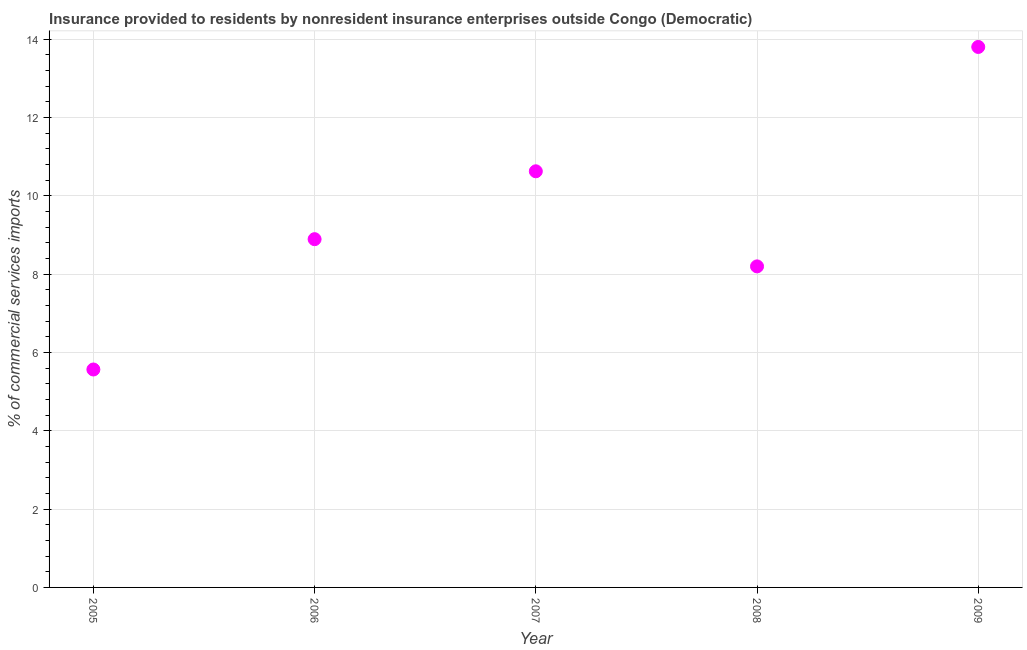What is the insurance provided by non-residents in 2009?
Your response must be concise. 13.8. Across all years, what is the maximum insurance provided by non-residents?
Give a very brief answer. 13.8. Across all years, what is the minimum insurance provided by non-residents?
Give a very brief answer. 5.57. In which year was the insurance provided by non-residents maximum?
Give a very brief answer. 2009. In which year was the insurance provided by non-residents minimum?
Offer a terse response. 2005. What is the sum of the insurance provided by non-residents?
Your answer should be very brief. 47.09. What is the difference between the insurance provided by non-residents in 2005 and 2008?
Your answer should be compact. -2.63. What is the average insurance provided by non-residents per year?
Your response must be concise. 9.42. What is the median insurance provided by non-residents?
Your response must be concise. 8.89. In how many years, is the insurance provided by non-residents greater than 9.2 %?
Your response must be concise. 2. Do a majority of the years between 2009 and 2007 (inclusive) have insurance provided by non-residents greater than 11.6 %?
Offer a very short reply. No. What is the ratio of the insurance provided by non-residents in 2008 to that in 2009?
Ensure brevity in your answer.  0.59. Is the insurance provided by non-residents in 2005 less than that in 2006?
Your answer should be very brief. Yes. Is the difference between the insurance provided by non-residents in 2005 and 2006 greater than the difference between any two years?
Your answer should be very brief. No. What is the difference between the highest and the second highest insurance provided by non-residents?
Provide a succinct answer. 3.18. Is the sum of the insurance provided by non-residents in 2006 and 2008 greater than the maximum insurance provided by non-residents across all years?
Your answer should be very brief. Yes. What is the difference between the highest and the lowest insurance provided by non-residents?
Make the answer very short. 8.24. In how many years, is the insurance provided by non-residents greater than the average insurance provided by non-residents taken over all years?
Provide a short and direct response. 2. What is the difference between two consecutive major ticks on the Y-axis?
Offer a very short reply. 2. Are the values on the major ticks of Y-axis written in scientific E-notation?
Give a very brief answer. No. Does the graph contain any zero values?
Provide a short and direct response. No. Does the graph contain grids?
Keep it short and to the point. Yes. What is the title of the graph?
Your response must be concise. Insurance provided to residents by nonresident insurance enterprises outside Congo (Democratic). What is the label or title of the X-axis?
Make the answer very short. Year. What is the label or title of the Y-axis?
Provide a succinct answer. % of commercial services imports. What is the % of commercial services imports in 2005?
Make the answer very short. 5.57. What is the % of commercial services imports in 2006?
Your answer should be very brief. 8.89. What is the % of commercial services imports in 2007?
Your response must be concise. 10.63. What is the % of commercial services imports in 2008?
Keep it short and to the point. 8.2. What is the % of commercial services imports in 2009?
Offer a very short reply. 13.8. What is the difference between the % of commercial services imports in 2005 and 2006?
Ensure brevity in your answer.  -3.33. What is the difference between the % of commercial services imports in 2005 and 2007?
Your answer should be compact. -5.06. What is the difference between the % of commercial services imports in 2005 and 2008?
Keep it short and to the point. -2.63. What is the difference between the % of commercial services imports in 2005 and 2009?
Your response must be concise. -8.24. What is the difference between the % of commercial services imports in 2006 and 2007?
Offer a terse response. -1.73. What is the difference between the % of commercial services imports in 2006 and 2008?
Give a very brief answer. 0.7. What is the difference between the % of commercial services imports in 2006 and 2009?
Provide a short and direct response. -4.91. What is the difference between the % of commercial services imports in 2007 and 2008?
Offer a very short reply. 2.43. What is the difference between the % of commercial services imports in 2007 and 2009?
Your answer should be compact. -3.18. What is the difference between the % of commercial services imports in 2008 and 2009?
Give a very brief answer. -5.6. What is the ratio of the % of commercial services imports in 2005 to that in 2006?
Offer a very short reply. 0.63. What is the ratio of the % of commercial services imports in 2005 to that in 2007?
Keep it short and to the point. 0.52. What is the ratio of the % of commercial services imports in 2005 to that in 2008?
Keep it short and to the point. 0.68. What is the ratio of the % of commercial services imports in 2005 to that in 2009?
Provide a succinct answer. 0.4. What is the ratio of the % of commercial services imports in 2006 to that in 2007?
Offer a terse response. 0.84. What is the ratio of the % of commercial services imports in 2006 to that in 2008?
Give a very brief answer. 1.08. What is the ratio of the % of commercial services imports in 2006 to that in 2009?
Offer a very short reply. 0.64. What is the ratio of the % of commercial services imports in 2007 to that in 2008?
Give a very brief answer. 1.3. What is the ratio of the % of commercial services imports in 2007 to that in 2009?
Provide a succinct answer. 0.77. What is the ratio of the % of commercial services imports in 2008 to that in 2009?
Your answer should be compact. 0.59. 